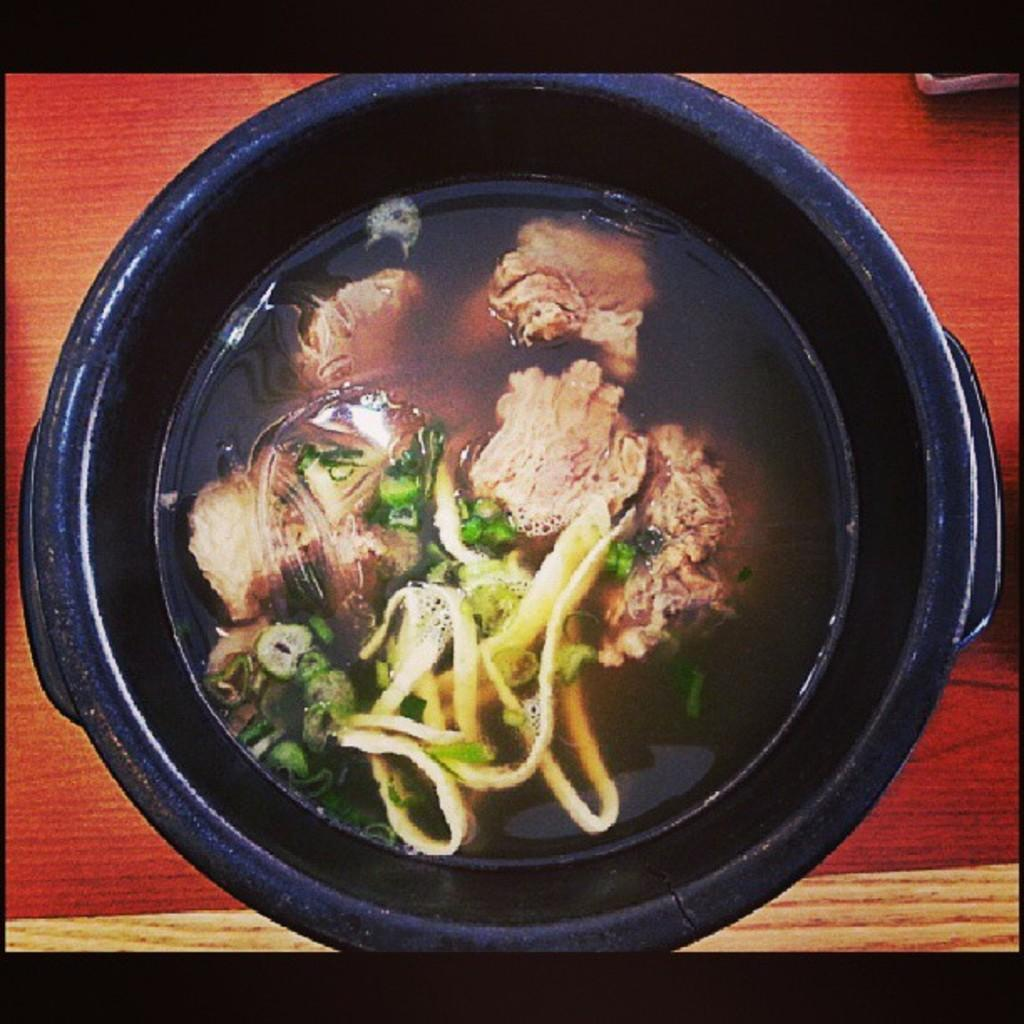What is located on the wooden surface in the image? There is a bowl on the wooden surface. What is inside the bowl? There is food in the bowl. What type of locket can be seen hanging from the wooden surface in the image? There is no locket present in the image; it only features a bowl on a wooden surface. What kind of spark can be observed coming from the food in the bowl? There is no spark visible in the image, as it only features a bowl with food on a wooden surface. 